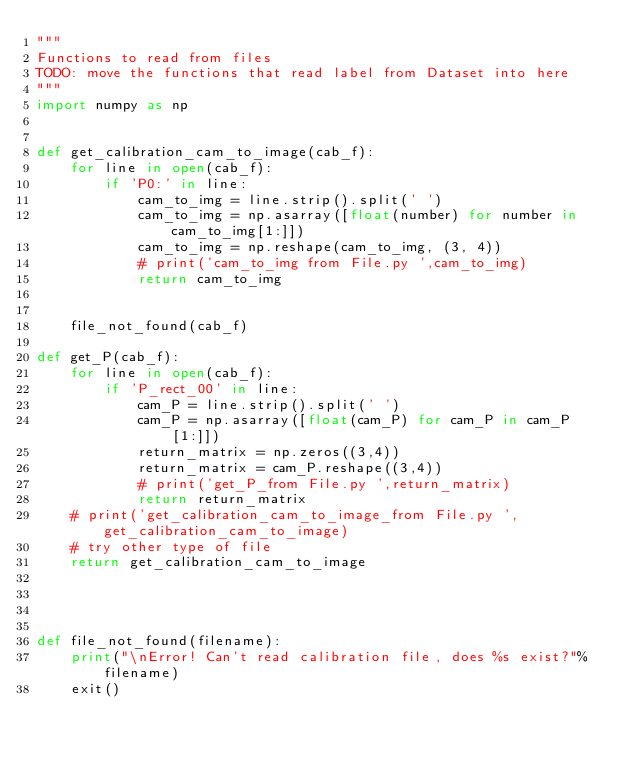<code> <loc_0><loc_0><loc_500><loc_500><_Python_>"""
Functions to read from files
TODO: move the functions that read label from Dataset into here
"""
import numpy as np


def get_calibration_cam_to_image(cab_f):
    for line in open(cab_f):
        if 'P0:' in line:
            cam_to_img = line.strip().split(' ')
            cam_to_img = np.asarray([float(number) for number in cam_to_img[1:]])
            cam_to_img = np.reshape(cam_to_img, (3, 4))
            # print('cam_to_img from File.py ',cam_to_img)
            return cam_to_img


    file_not_found(cab_f)

def get_P(cab_f):
    for line in open(cab_f):
        if 'P_rect_00' in line:
            cam_P = line.strip().split(' ')
            cam_P = np.asarray([float(cam_P) for cam_P in cam_P[1:]])
            return_matrix = np.zeros((3,4))
            return_matrix = cam_P.reshape((3,4))
            # print('get_P_from File.py ',return_matrix)
            return return_matrix
    # print('get_calibration_cam_to_image_from File.py ',get_calibration_cam_to_image)
    # try other type of file
    return get_calibration_cam_to_image




def file_not_found(filename):
    print("\nError! Can't read calibration file, does %s exist?"%filename)
    exit()
</code> 